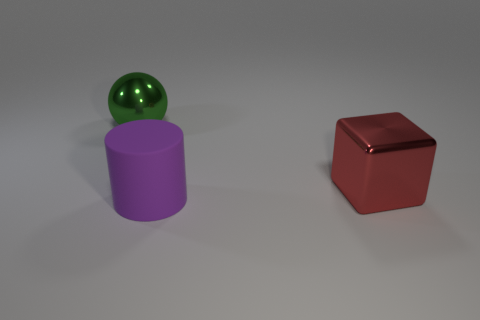Add 3 big brown matte cylinders. How many objects exist? 6 Subtract all blocks. How many objects are left? 2 Subtract 0 green blocks. How many objects are left? 3 Subtract all purple spheres. Subtract all gray cylinders. How many spheres are left? 1 Subtract all big red blocks. Subtract all green metallic objects. How many objects are left? 1 Add 3 big purple matte cylinders. How many big purple matte cylinders are left? 4 Add 3 large purple matte cylinders. How many large purple matte cylinders exist? 4 